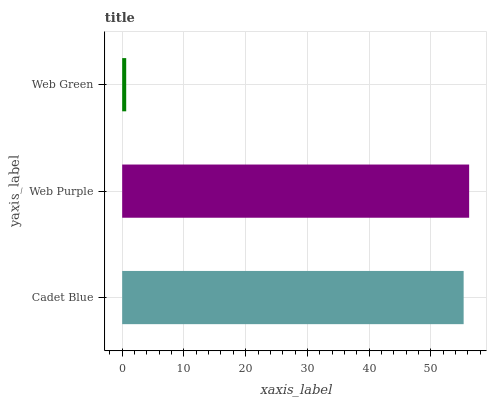Is Web Green the minimum?
Answer yes or no. Yes. Is Web Purple the maximum?
Answer yes or no. Yes. Is Web Purple the minimum?
Answer yes or no. No. Is Web Green the maximum?
Answer yes or no. No. Is Web Purple greater than Web Green?
Answer yes or no. Yes. Is Web Green less than Web Purple?
Answer yes or no. Yes. Is Web Green greater than Web Purple?
Answer yes or no. No. Is Web Purple less than Web Green?
Answer yes or no. No. Is Cadet Blue the high median?
Answer yes or no. Yes. Is Cadet Blue the low median?
Answer yes or no. Yes. Is Web Green the high median?
Answer yes or no. No. Is Web Purple the low median?
Answer yes or no. No. 